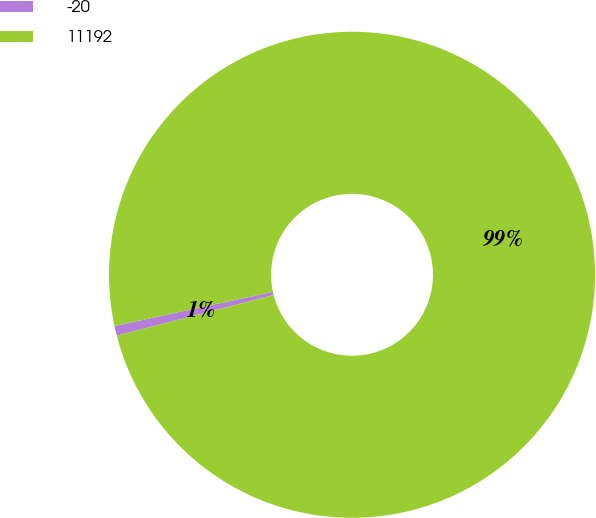<chart> <loc_0><loc_0><loc_500><loc_500><pie_chart><fcel>-20<fcel>11192<nl><fcel>0.65%<fcel>99.35%<nl></chart> 